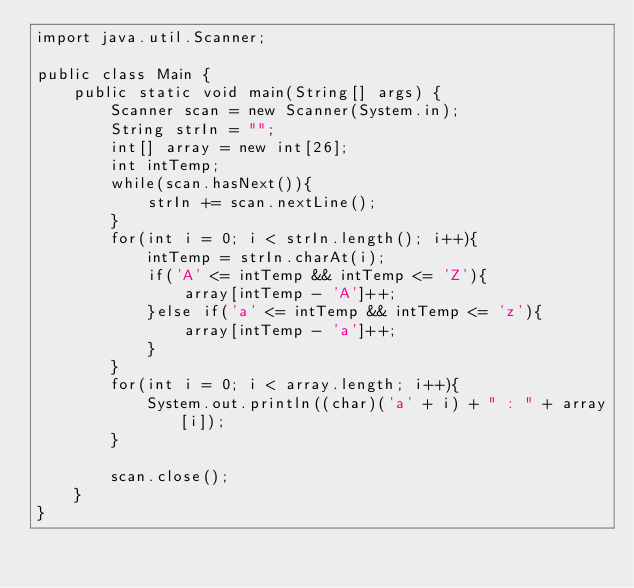Convert code to text. <code><loc_0><loc_0><loc_500><loc_500><_Java_>import java.util.Scanner;
 
public class Main {
    public static void main(String[] args) {
        Scanner scan = new Scanner(System.in);
        String strIn = "";
        int[] array = new int[26];
        int intTemp;
        while(scan.hasNext()){
            strIn += scan.nextLine();
        }
        for(int i = 0; i < strIn.length(); i++){
            intTemp = strIn.charAt(i);
            if('A' <= intTemp && intTemp <= 'Z'){
                array[intTemp - 'A']++;
            }else if('a' <= intTemp && intTemp <= 'z'){
                array[intTemp - 'a']++;
            }
        }
        for(int i = 0; i < array.length; i++){
            System.out.println((char)('a' + i) + " : " + array[i]);
        }
 
        scan.close();
    }
}</code> 